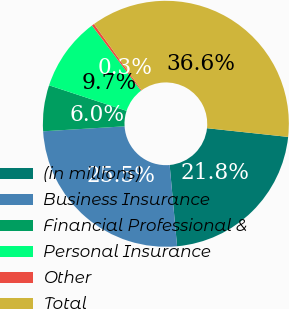Convert chart. <chart><loc_0><loc_0><loc_500><loc_500><pie_chart><fcel>(in millions)<fcel>Business Insurance<fcel>Financial Professional &<fcel>Personal Insurance<fcel>Other<fcel>Total<nl><fcel>21.85%<fcel>25.48%<fcel>6.04%<fcel>9.67%<fcel>0.33%<fcel>36.64%<nl></chart> 